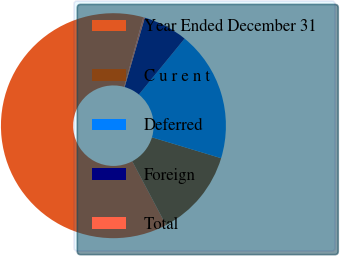Convert chart to OTSL. <chart><loc_0><loc_0><loc_500><loc_500><pie_chart><fcel>Year Ended December 31<fcel>C u r e n t<fcel>Deferred<fcel>Foreign<fcel>Total<nl><fcel>62.04%<fcel>12.58%<fcel>18.76%<fcel>6.4%<fcel>0.22%<nl></chart> 